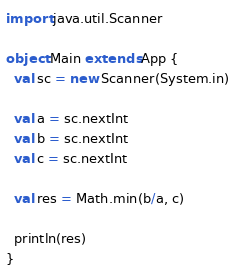<code> <loc_0><loc_0><loc_500><loc_500><_Scala_>import java.util.Scanner

object Main extends App {
  val sc = new Scanner(System.in)

  val a = sc.nextInt
  val b = sc.nextInt
  val c = sc.nextInt

  val res = Math.min(b/a, c)

  println(res)
}</code> 